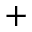<formula> <loc_0><loc_0><loc_500><loc_500>+</formula> 